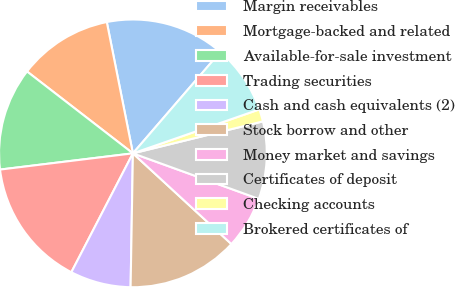Convert chart to OTSL. <chart><loc_0><loc_0><loc_500><loc_500><pie_chart><fcel>Margin receivables<fcel>Mortgage-backed and related<fcel>Available-for-sale investment<fcel>Trading securities<fcel>Cash and cash equivalents (2)<fcel>Stock borrow and other<fcel>Money market and savings<fcel>Certificates of deposit<fcel>Checking accounts<fcel>Brokered certificates of<nl><fcel>14.45%<fcel>11.4%<fcel>12.41%<fcel>15.46%<fcel>7.33%<fcel>13.43%<fcel>6.32%<fcel>9.36%<fcel>1.49%<fcel>8.35%<nl></chart> 